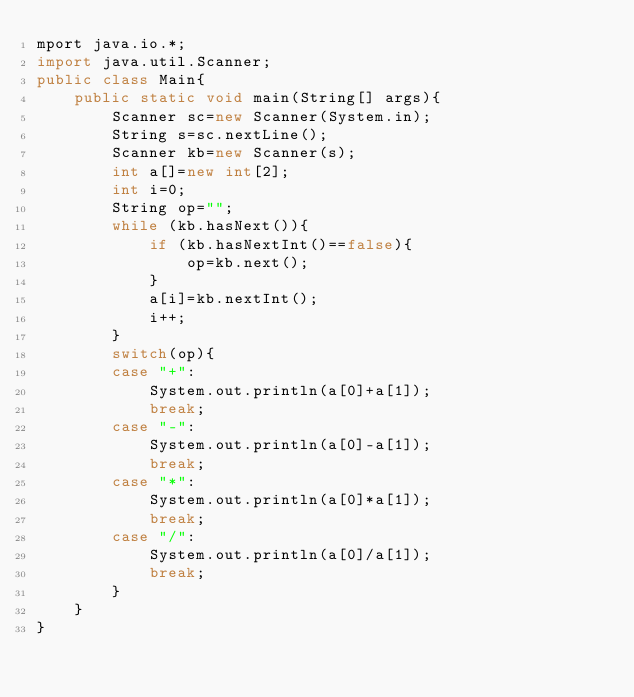<code> <loc_0><loc_0><loc_500><loc_500><_Java_>mport java.io.*;
import java.util.Scanner;
public class Main{
    public static void main(String[] args){
        Scanner sc=new Scanner(System.in);
        String s=sc.nextLine();
        Scanner kb=new Scanner(s);
        int a[]=new int[2];
        int i=0;
        String op="";
        while (kb.hasNext()){
            if (kb.hasNextInt()==false){
                op=kb.next();
            }
            a[i]=kb.nextInt();
            i++;
        }
        switch(op){
        case "+":
            System.out.println(a[0]+a[1]);
            break;
        case "-":
            System.out.println(a[0]-a[1]);
            break;
        case "*":
            System.out.println(a[0]*a[1]);
            break;
        case "/":
            System.out.println(a[0]/a[1]);
            break;
        }
    }
}</code> 